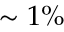<formula> <loc_0><loc_0><loc_500><loc_500>\sim 1 \%</formula> 